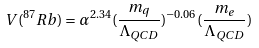<formula> <loc_0><loc_0><loc_500><loc_500>V ( ^ { 8 7 } R b ) = \alpha ^ { 2 . 3 4 } ( \frac { m _ { q } } { \Lambda _ { Q C D } } ) ^ { - 0 . 0 6 } ( \frac { m _ { e } } { \Lambda _ { Q C D } } )</formula> 